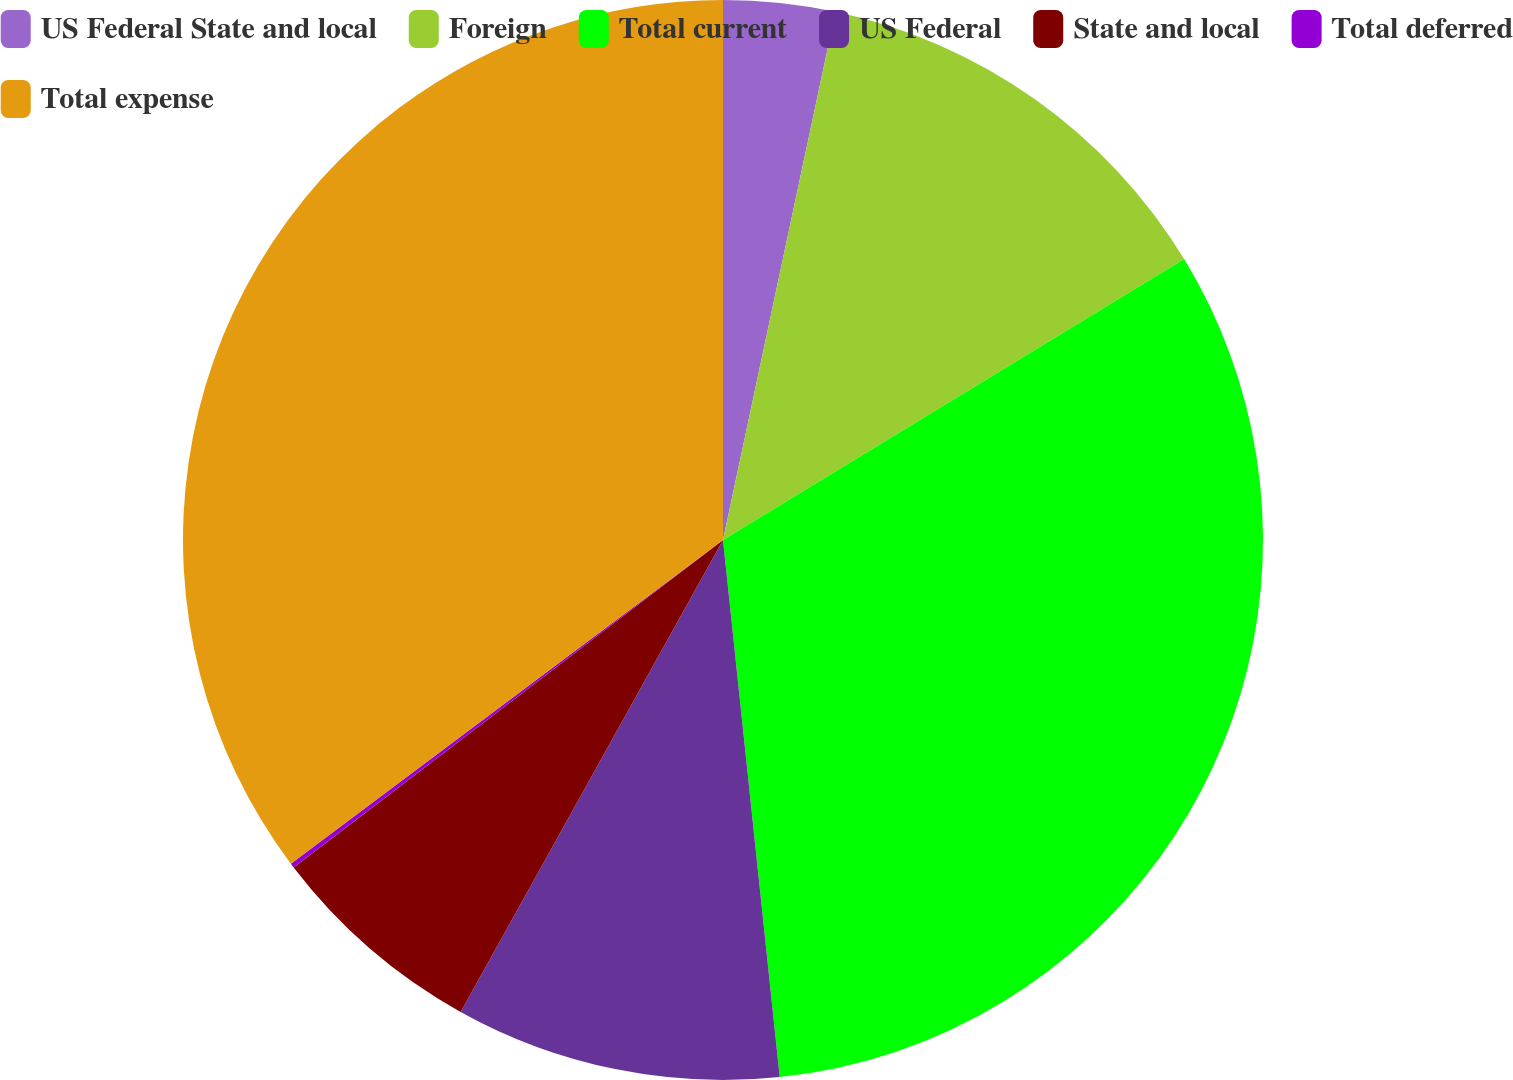Convert chart to OTSL. <chart><loc_0><loc_0><loc_500><loc_500><pie_chart><fcel>US Federal State and local<fcel>Foreign<fcel>Total current<fcel>US Federal<fcel>State and local<fcel>Total deferred<fcel>Total expense<nl><fcel>3.34%<fcel>12.95%<fcel>32.03%<fcel>9.75%<fcel>6.55%<fcel>0.14%<fcel>35.23%<nl></chart> 